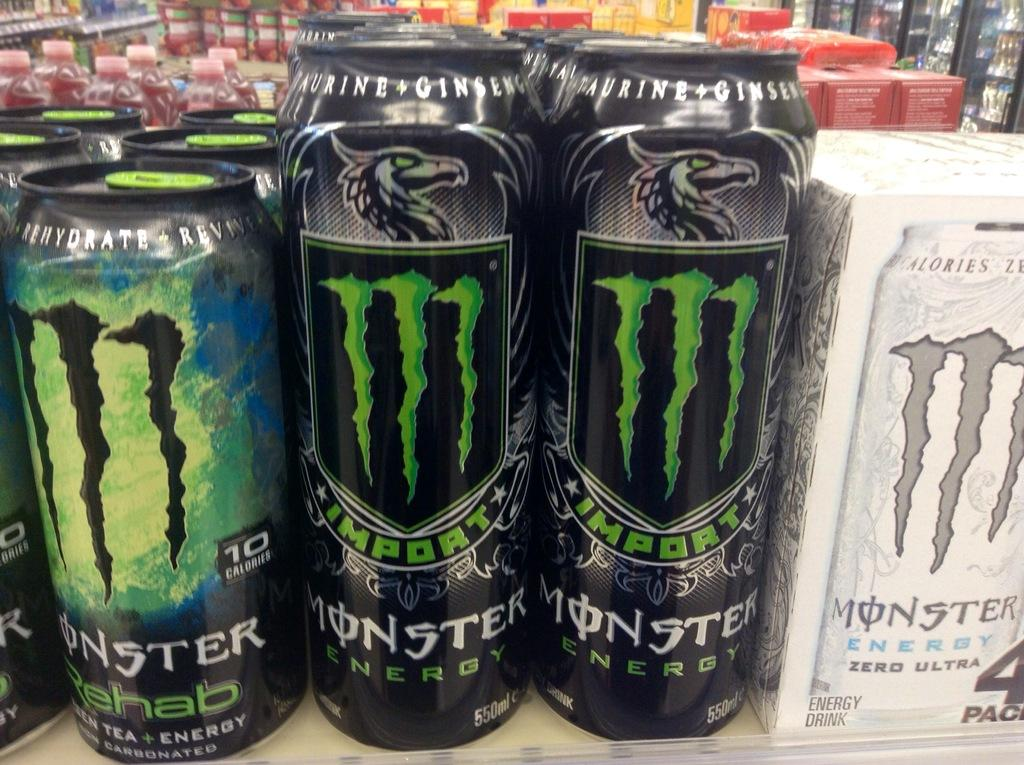<image>
Give a short and clear explanation of the subsequent image. Many Monster energy drinks sit next to each other on a shelf in a store. 